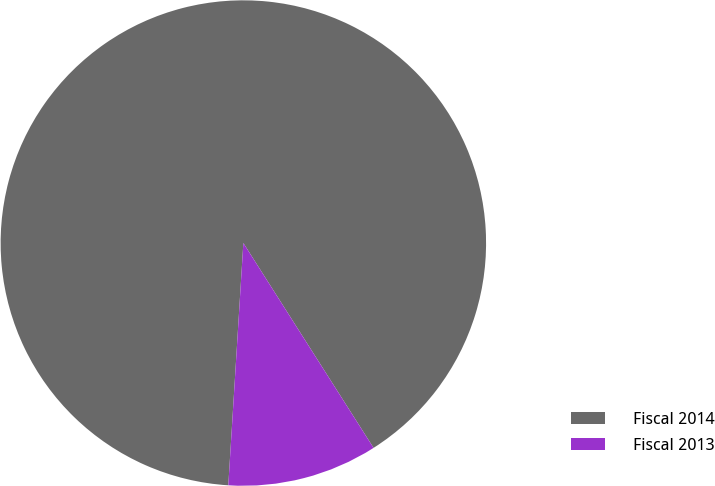Convert chart to OTSL. <chart><loc_0><loc_0><loc_500><loc_500><pie_chart><fcel>Fiscal 2014<fcel>Fiscal 2013<nl><fcel>90.0%<fcel>10.0%<nl></chart> 